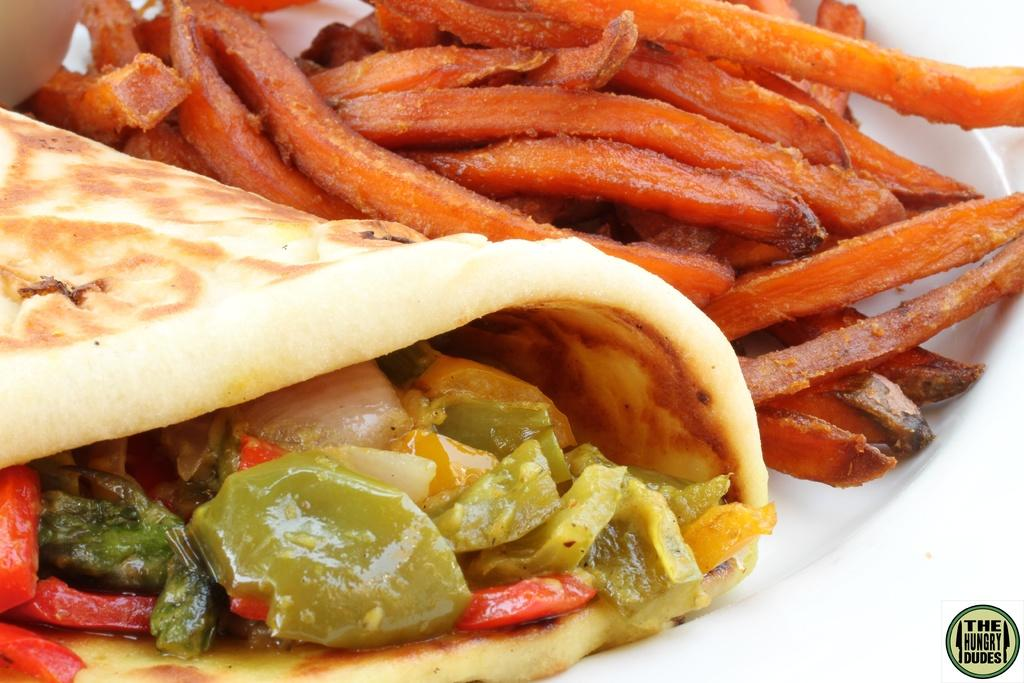What can be found on the left side of the image? There are food items on the left side of the image. What type of food is on the right side of the image? There are french fries in a white color plate on the right side of the image. What symbol is present at the bottom of the image? There is a symbol of a plate at the bottom of the image. What thrilling word can be seen in the title of the image? There is no title present in the image, and therefore no thrilling word can be observed. 